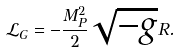<formula> <loc_0><loc_0><loc_500><loc_500>\mathcal { L } _ { G } = - \frac { M _ { P } ^ { 2 } } { 2 } \sqrt { - g } R .</formula> 